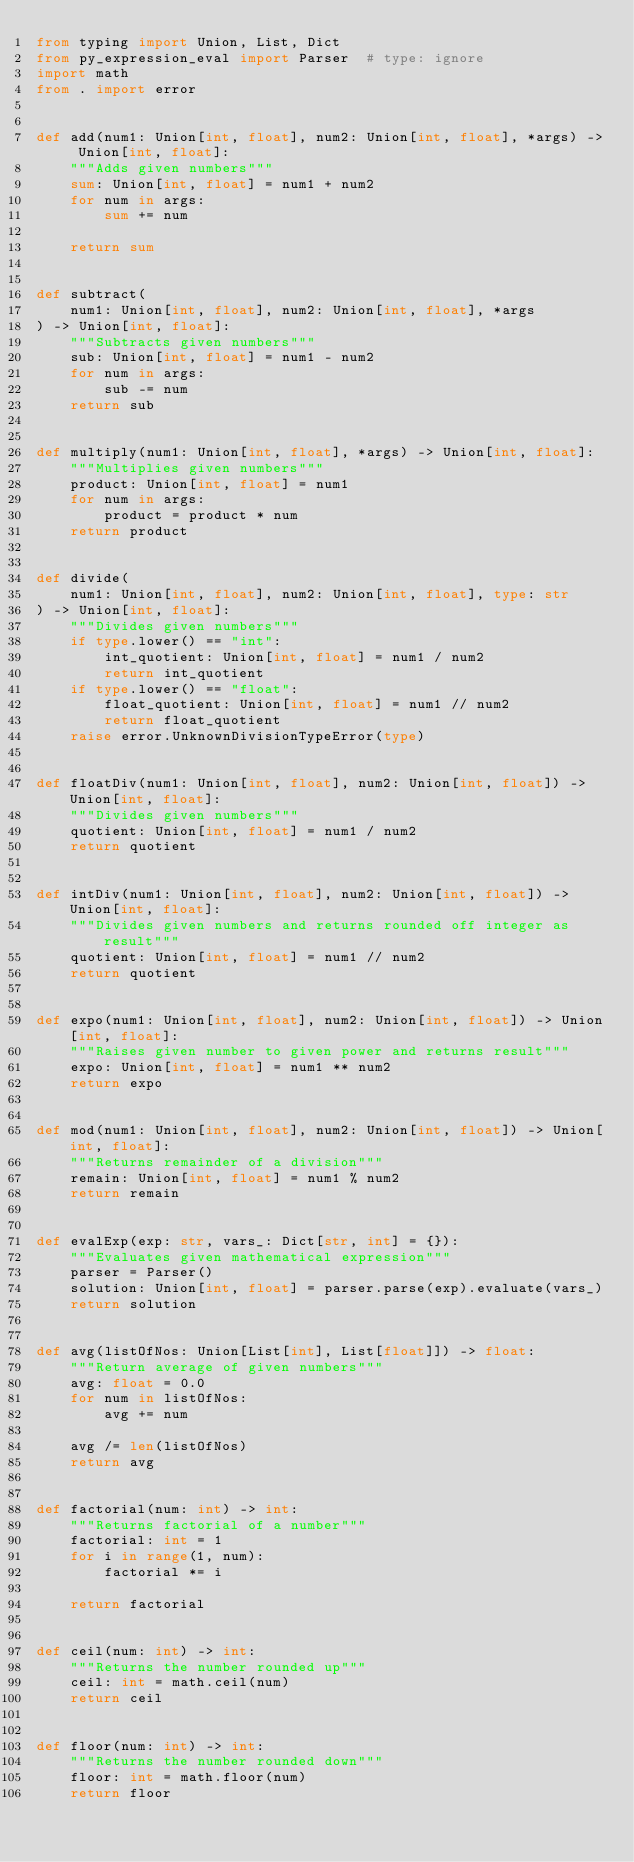<code> <loc_0><loc_0><loc_500><loc_500><_Python_>from typing import Union, List, Dict
from py_expression_eval import Parser  # type: ignore
import math
from . import error


def add(num1: Union[int, float], num2: Union[int, float], *args) -> Union[int, float]:
    """Adds given numbers"""
    sum: Union[int, float] = num1 + num2
    for num in args:
        sum += num

    return sum


def subtract(
    num1: Union[int, float], num2: Union[int, float], *args
) -> Union[int, float]:
    """Subtracts given numbers"""
    sub: Union[int, float] = num1 - num2
    for num in args:
        sub -= num
    return sub


def multiply(num1: Union[int, float], *args) -> Union[int, float]:
    """Multiplies given numbers"""
    product: Union[int, float] = num1
    for num in args:
        product = product * num
    return product


def divide(
    num1: Union[int, float], num2: Union[int, float], type: str
) -> Union[int, float]:
    """Divides given numbers"""
    if type.lower() == "int":
        int_quotient: Union[int, float] = num1 / num2
        return int_quotient
    if type.lower() == "float":
        float_quotient: Union[int, float] = num1 // num2
        return float_quotient
    raise error.UnknownDivisionTypeError(type)


def floatDiv(num1: Union[int, float], num2: Union[int, float]) -> Union[int, float]:
    """Divides given numbers"""
    quotient: Union[int, float] = num1 / num2
    return quotient


def intDiv(num1: Union[int, float], num2: Union[int, float]) -> Union[int, float]:
    """Divides given numbers and returns rounded off integer as result"""
    quotient: Union[int, float] = num1 // num2
    return quotient


def expo(num1: Union[int, float], num2: Union[int, float]) -> Union[int, float]:
    """Raises given number to given power and returns result"""
    expo: Union[int, float] = num1 ** num2
    return expo


def mod(num1: Union[int, float], num2: Union[int, float]) -> Union[int, float]:
    """Returns remainder of a division"""
    remain: Union[int, float] = num1 % num2
    return remain


def evalExp(exp: str, vars_: Dict[str, int] = {}):
    """Evaluates given mathematical expression"""
    parser = Parser()
    solution: Union[int, float] = parser.parse(exp).evaluate(vars_)
    return solution


def avg(listOfNos: Union[List[int], List[float]]) -> float:
    """Return average of given numbers"""
    avg: float = 0.0
    for num in listOfNos:
        avg += num

    avg /= len(listOfNos)
    return avg


def factorial(num: int) -> int:
    """Returns factorial of a number"""
    factorial: int = 1
    for i in range(1, num):
        factorial *= i

    return factorial


def ceil(num: int) -> int:
    """Returns the number rounded up"""
    ceil: int = math.ceil(num)
    return ceil


def floor(num: int) -> int:
    """Returns the number rounded down"""
    floor: int = math.floor(num)
    return floor
</code> 